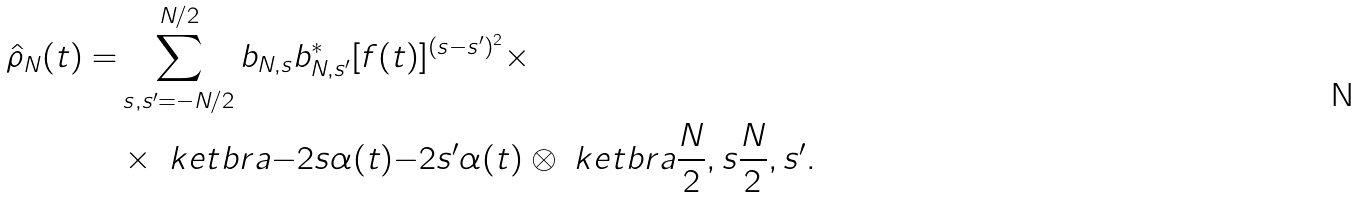<formula> <loc_0><loc_0><loc_500><loc_500>\hat { \rho } _ { N } ( t ) = & \sum _ { s , s ^ { \prime } = - N / 2 } ^ { N / 2 } b _ { N , s } b _ { N , s ^ { \prime } } ^ { * } [ f ( t ) ] ^ { ( s - s ^ { \prime } ) ^ { 2 } } \times \\ & \times \ k e t b r a { - 2 s \alpha ( t ) } { - 2 s ^ { \prime } \alpha ( t ) } \otimes \ k e t b r a { \frac { N } { 2 } , s } { \frac { N } { 2 } , s ^ { \prime } } .</formula> 